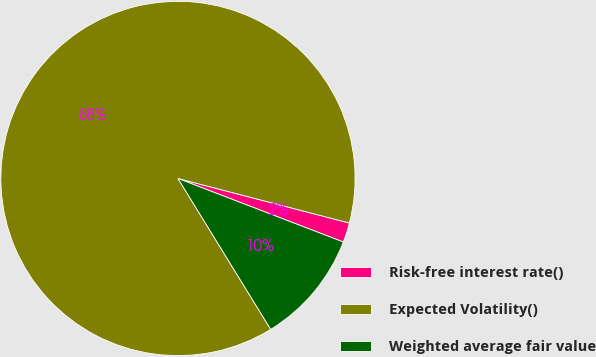Convert chart. <chart><loc_0><loc_0><loc_500><loc_500><pie_chart><fcel>Risk-free interest rate()<fcel>Expected Volatility()<fcel>Weighted average fair value<nl><fcel>1.79%<fcel>87.82%<fcel>10.39%<nl></chart> 